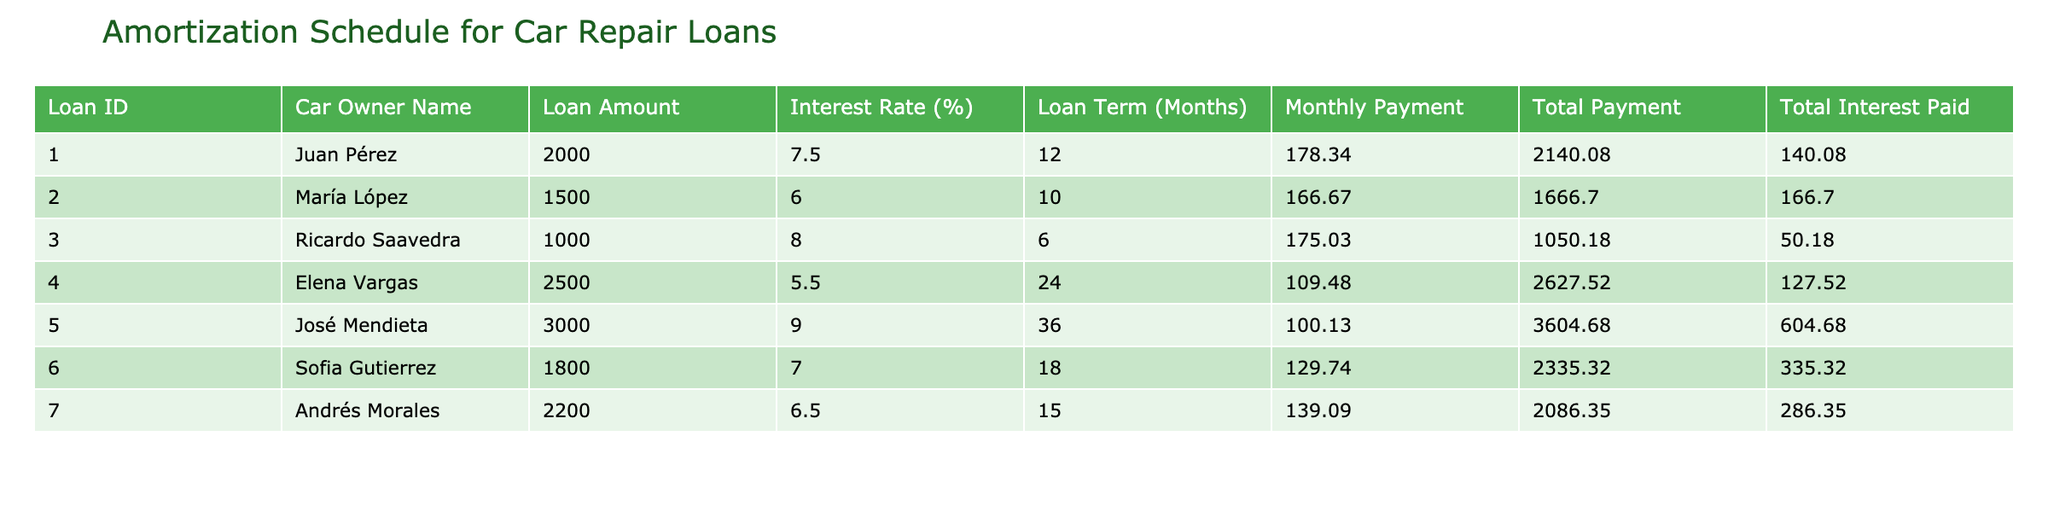What is the total amount paid by Juan Pérez? Juan Pérez's total payment amount is directly given in the table under the "Total Payment" column. His total payment is listed as 2140.08.
Answer: 2140.08 What is the monthly payment for the car loan with the highest interest rate? The highest interest rate in the table is 9.0%, which belongs to José Mendieta. His monthly payment is listed as 100.13.
Answer: 100.13 Which car owner has the lowest total interest paid? By reviewing the "Total Interest Paid" column, the lowest value is 50.18, attributed to Ricardo Saavedra.
Answer: Ricardo Saavedra What is the combined total interest paid for all loans? To find the combined total interest paid, sum all values in the "Total Interest Paid" column: (140.08 + 166.70 + 50.18 + 127.52 + 604.68 + 335.32 + 286.35) = 1710.83.
Answer: 1710.83 Is María López's loan term longer than Ricardo Saavedra's loan term? María López's loan term is 10 months, while Ricardo Saavedra's is 6 months. Since 10 is greater than 6, the answer is yes.
Answer: Yes What is the average monthly payment across all loans? To calculate the average monthly payment, sum all monthly payments (178.34 + 166.67 + 175.03 + 109.48 + 100.13 + 129.74 + 139.09) = 999.48, then divide by the number of loans (7) which results in 999.48 / 7 = 142.71.
Answer: 142.71 Which car owner has a lower total payment, Sofia Gutierrez or Elena Vargas? Sofia Gutierrez's total payment is listed as 2335.32 and Elena Vargas's as 2627.52. Comparing these values shows that Sofia Gutierrez has the lower total payment.
Answer: Sofia Gutierrez How many loans have a loan amount greater than 2000? By analyzing the "Loan Amount" column, the loan amounts greater than 2000 belong to Elena Vargas (2500) and José Mendieta (3000). Therefore, there are 2 loans exceeding 2000.
Answer: 2 Is the average interest rate above 7%? To find the average interest rate: (7.5 + 6.0 + 8.0 + 5.5 + 9.0 + 7.0 + 6.5) = 49.5, which divided by the number of loans (7) equals 7.07. Since 7.07 is greater than 7, the answer is yes.
Answer: Yes 